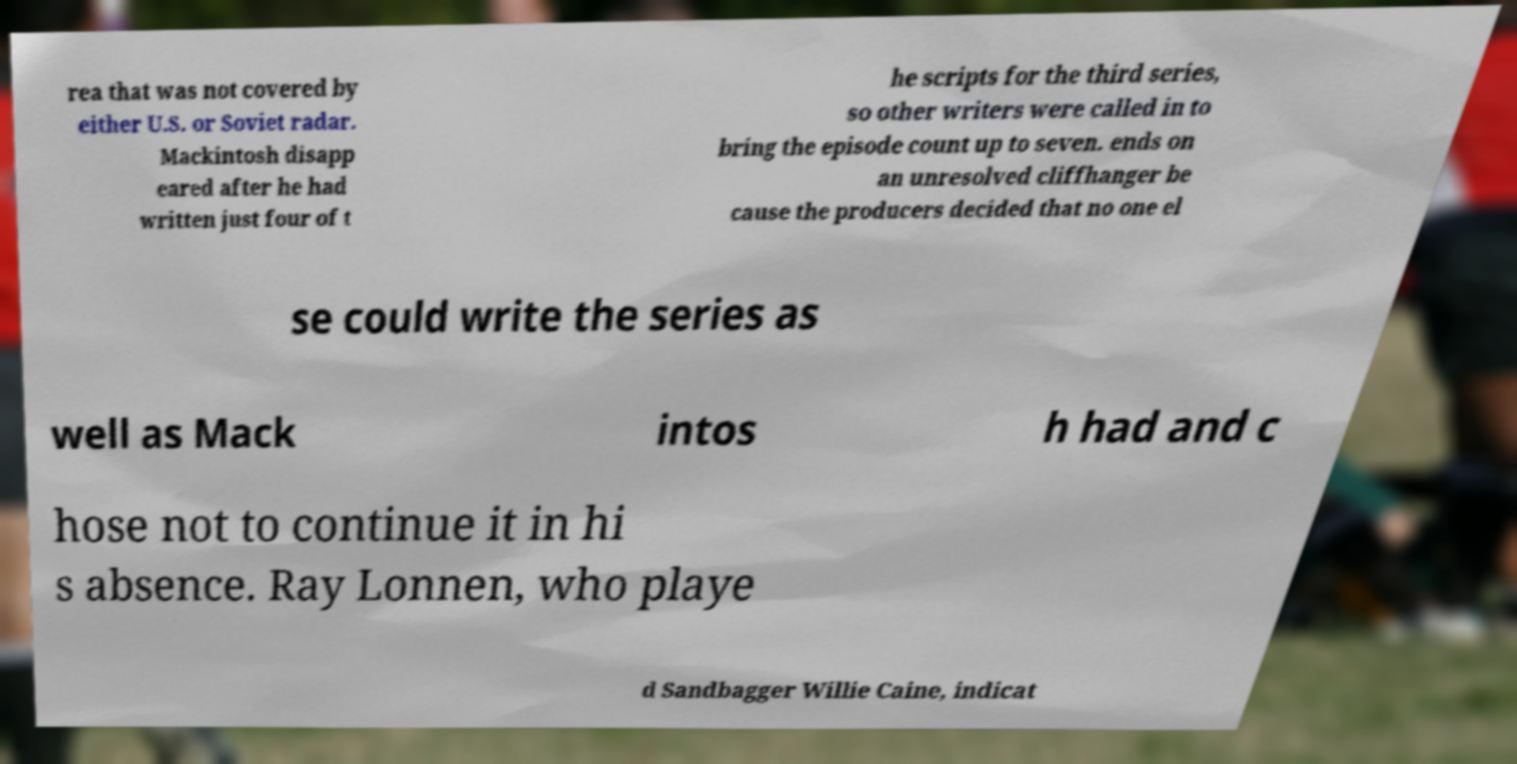What messages or text are displayed in this image? I need them in a readable, typed format. rea that was not covered by either U.S. or Soviet radar. Mackintosh disapp eared after he had written just four of t he scripts for the third series, so other writers were called in to bring the episode count up to seven. ends on an unresolved cliffhanger be cause the producers decided that no one el se could write the series as well as Mack intos h had and c hose not to continue it in hi s absence. Ray Lonnen, who playe d Sandbagger Willie Caine, indicat 